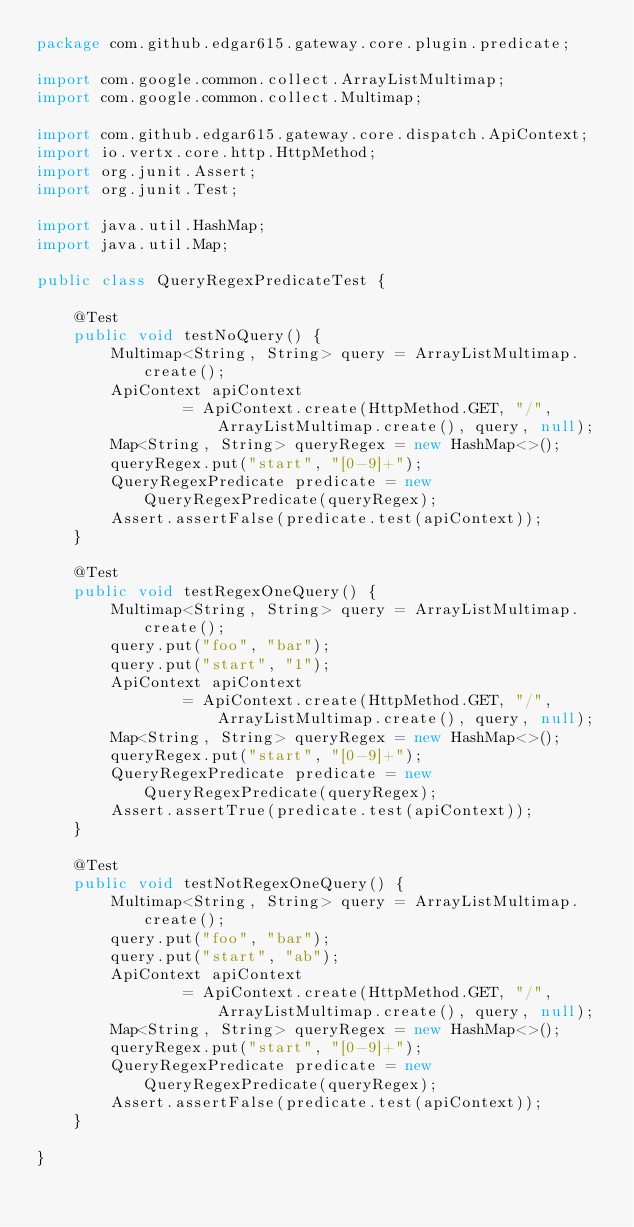Convert code to text. <code><loc_0><loc_0><loc_500><loc_500><_Java_>package com.github.edgar615.gateway.core.plugin.predicate;

import com.google.common.collect.ArrayListMultimap;
import com.google.common.collect.Multimap;

import com.github.edgar615.gateway.core.dispatch.ApiContext;
import io.vertx.core.http.HttpMethod;
import org.junit.Assert;
import org.junit.Test;

import java.util.HashMap;
import java.util.Map;

public class QueryRegexPredicateTest {

    @Test
    public void testNoQuery() {
        Multimap<String, String> query = ArrayListMultimap.create();
        ApiContext apiContext
                = ApiContext.create(HttpMethod.GET, "/", ArrayListMultimap.create(), query, null);
        Map<String, String> queryRegex = new HashMap<>();
        queryRegex.put("start", "[0-9]+");
        QueryRegexPredicate predicate = new QueryRegexPredicate(queryRegex);
        Assert.assertFalse(predicate.test(apiContext));
    }

    @Test
    public void testRegexOneQuery() {
        Multimap<String, String> query = ArrayListMultimap.create();
        query.put("foo", "bar");
        query.put("start", "1");
        ApiContext apiContext
                = ApiContext.create(HttpMethod.GET, "/", ArrayListMultimap.create(), query, null);
        Map<String, String> queryRegex = new HashMap<>();
        queryRegex.put("start", "[0-9]+");
        QueryRegexPredicate predicate = new QueryRegexPredicate(queryRegex);
        Assert.assertTrue(predicate.test(apiContext));
    }

    @Test
    public void testNotRegexOneQuery() {
        Multimap<String, String> query = ArrayListMultimap.create();
        query.put("foo", "bar");
        query.put("start", "ab");
        ApiContext apiContext
                = ApiContext.create(HttpMethod.GET, "/", ArrayListMultimap.create(), query, null);
        Map<String, String> queryRegex = new HashMap<>();
        queryRegex.put("start", "[0-9]+");
        QueryRegexPredicate predicate = new QueryRegexPredicate(queryRegex);
        Assert.assertFalse(predicate.test(apiContext));
    }

}
</code> 